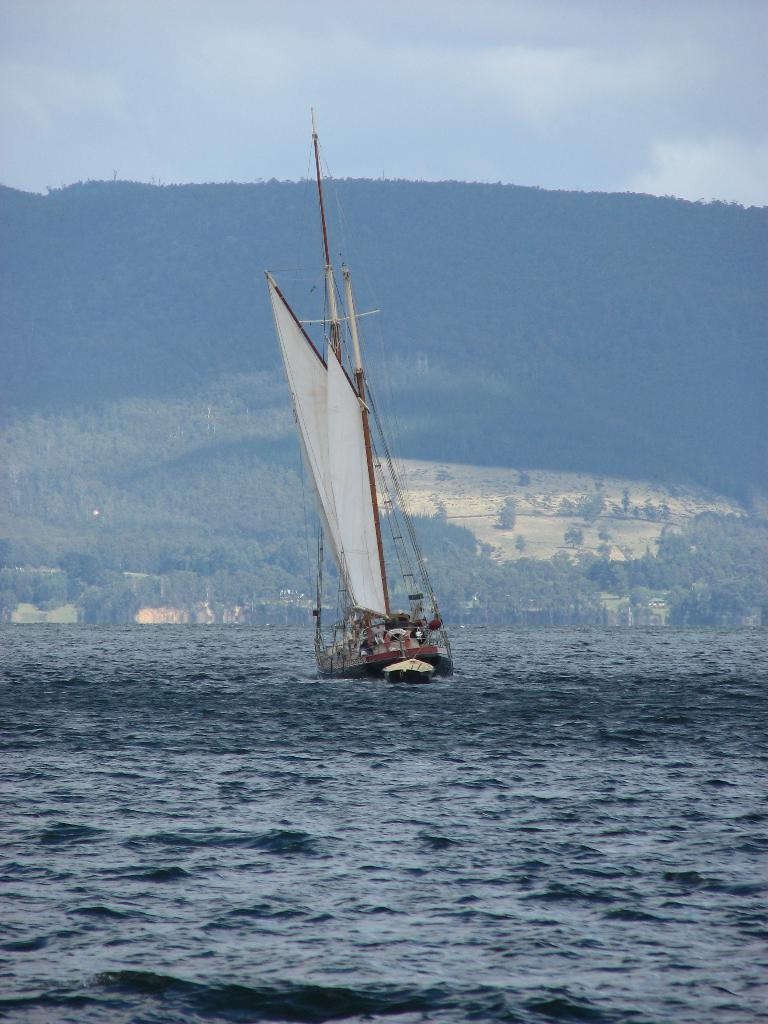What is the main subject of the image? There is a sailboat in the image. How is the sailboat positioned in the image? The sailboat is floating on the water. What can be seen in the background of the image? There are trees, hills, and a cloudy sky in the background of the image. Can you see a giraffe in the image? No, there is no giraffe present in the image. 